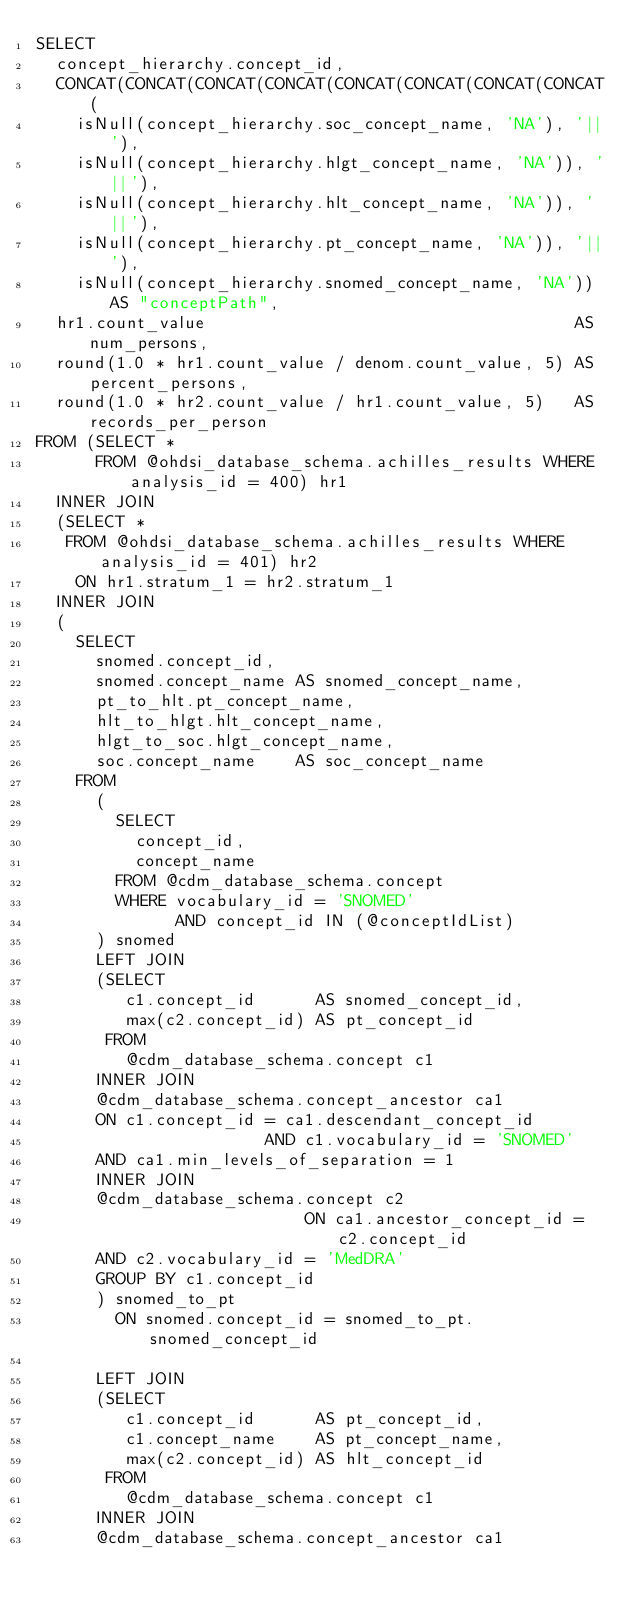Convert code to text. <code><loc_0><loc_0><loc_500><loc_500><_SQL_>SELECT
  concept_hierarchy.concept_id,
  CONCAT(CONCAT(CONCAT(CONCAT(CONCAT(CONCAT(CONCAT(CONCAT(
    isNull(concept_hierarchy.soc_concept_name, 'NA'), '||'),
    isNull(concept_hierarchy.hlgt_concept_name, 'NA')), '||'),
    isNull(concept_hierarchy.hlt_concept_name, 'NA')), '||'),
    isNull(concept_hierarchy.pt_concept_name, 'NA')), '||'),
    isNull(concept_hierarchy.snomed_concept_name, 'NA')) AS "conceptPath",
  hr1.count_value                                     AS num_persons,
  round(1.0 * hr1.count_value / denom.count_value, 5) AS percent_persons,
  round(1.0 * hr2.count_value / hr1.count_value, 5)   AS records_per_person
FROM (SELECT *
      FROM @ohdsi_database_schema.achilles_results WHERE analysis_id = 400) hr1
  INNER JOIN
  (SELECT *
   FROM @ohdsi_database_schema.achilles_results WHERE analysis_id = 401) hr2
    ON hr1.stratum_1 = hr2.stratum_1
  INNER JOIN
  (
    SELECT
      snomed.concept_id,
      snomed.concept_name AS snomed_concept_name,
      pt_to_hlt.pt_concept_name,
      hlt_to_hlgt.hlt_concept_name,
      hlgt_to_soc.hlgt_concept_name,
      soc.concept_name    AS soc_concept_name
    FROM
      (
        SELECT
          concept_id,
          concept_name
        FROM @cdm_database_schema.concept
        WHERE vocabulary_id = 'SNOMED'
              AND concept_id IN (@conceptIdList)
      ) snomed
      LEFT JOIN
      (SELECT
         c1.concept_id      AS snomed_concept_id,
         max(c2.concept_id) AS pt_concept_id
       FROM
         @cdm_database_schema.concept c1
      INNER JOIN
      @cdm_database_schema.concept_ancestor ca1
      ON c1.concept_id = ca1.descendant_concept_id
                       AND c1.vocabulary_id = 'SNOMED'
      AND ca1.min_levels_of_separation = 1
      INNER JOIN
      @cdm_database_schema.concept c2
                           ON ca1.ancestor_concept_id = c2.concept_id
      AND c2.vocabulary_id = 'MedDRA'
      GROUP BY c1.concept_id
      ) snomed_to_pt
        ON snomed.concept_id = snomed_to_pt.snomed_concept_id

      LEFT JOIN
      (SELECT
         c1.concept_id      AS pt_concept_id,
         c1.concept_name    AS pt_concept_name,
         max(c2.concept_id) AS hlt_concept_id
       FROM
         @cdm_database_schema.concept c1
      INNER JOIN
      @cdm_database_schema.concept_ancestor ca1</code> 